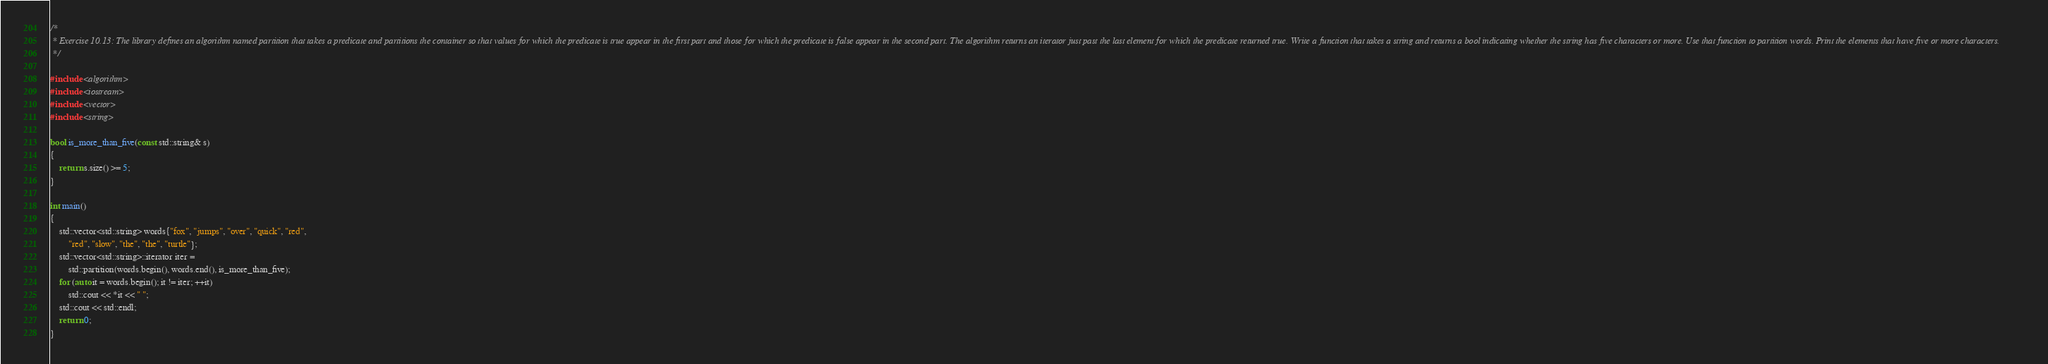<code> <loc_0><loc_0><loc_500><loc_500><_C++_>/*
 * Exercise 10.13: The library defines an algorithm named partition that takes a predicate and partitions the container so that values for which the predicate is true appear in the first part and those for which the predicate is false appear in the second part. The algorithm returns an iterator just past the last element for which the predicate returned true. Write a function that takes a string and returns a bool indicating whether the string has five characters or more. Use that function to partition words. Print the elements that have five or more characters.
 */

#include <algorithm>
#include <iostream>
#include <vector>
#include <string>

bool is_more_than_five(const std::string& s)
{
    return s.size() >= 5;
}

int main()
{
    std::vector<std::string> words{"fox", "jumps", "over", "quick", "red",
        "red", "slow", "the", "the", "turtle"};
    std::vector<std::string>::iterator iter =
        std::partition(words.begin(), words.end(), is_more_than_five);
    for (auto it = words.begin(); it != iter; ++it)
        std::cout << *it << " ";
    std::cout << std::endl;
    return 0;
}
</code> 